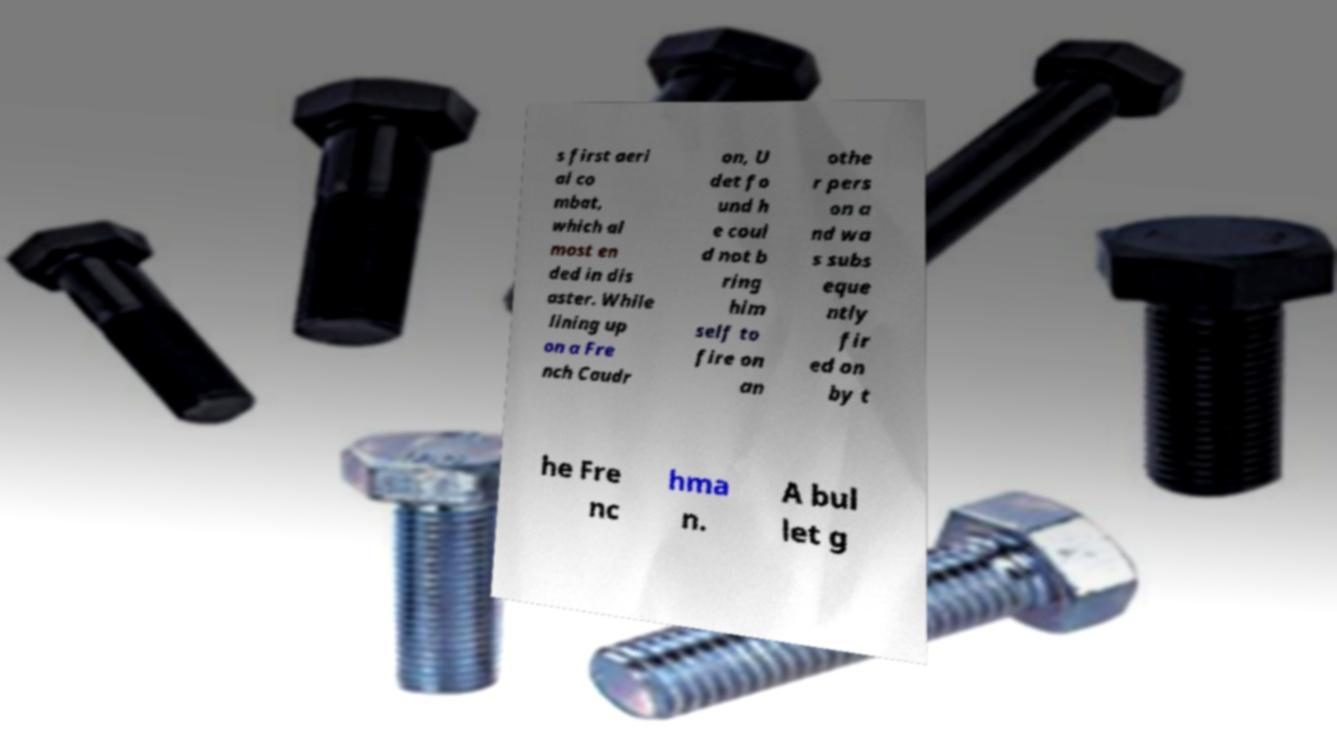What messages or text are displayed in this image? I need them in a readable, typed format. s first aeri al co mbat, which al most en ded in dis aster. While lining up on a Fre nch Caudr on, U det fo und h e coul d not b ring him self to fire on an othe r pers on a nd wa s subs eque ntly fir ed on by t he Fre nc hma n. A bul let g 